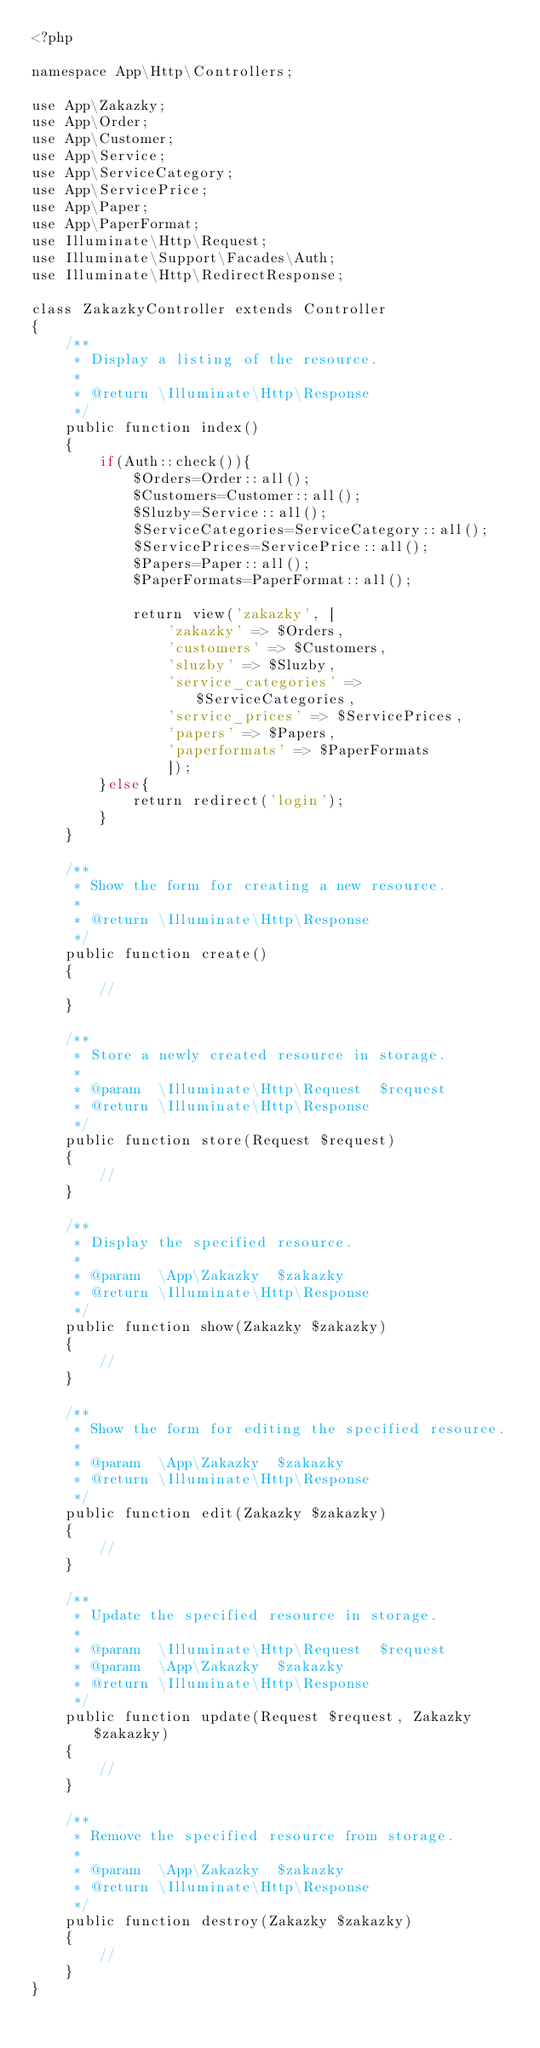<code> <loc_0><loc_0><loc_500><loc_500><_PHP_><?php

namespace App\Http\Controllers;

use App\Zakazky;
use App\Order;
use App\Customer;
use App\Service;
use App\ServiceCategory;
use App\ServicePrice;
use App\Paper;
use App\PaperFormat;
use Illuminate\Http\Request;
use Illuminate\Support\Facades\Auth;
use Illuminate\Http\RedirectResponse;

class ZakazkyController extends Controller
{
    /**
     * Display a listing of the resource.
     *
     * @return \Illuminate\Http\Response
     */
    public function index()
    {
        if(Auth::check()){
            $Orders=Order::all();
            $Customers=Customer::all();
            $Sluzby=Service::all();
            $ServiceCategories=ServiceCategory::all();
            $ServicePrices=ServicePrice::all();
            $Papers=Paper::all();
            $PaperFormats=PaperFormat::all();

            return view('zakazky', [
                'zakazky' => $Orders, 
                'customers' => $Customers, 
                'sluzby' => $Sluzby, 
                'service_categories' => $ServiceCategories, 
                'service_prices' => $ServicePrices,
                'papers' => $Papers, 
                'paperformats' => $PaperFormats 
                ]);
        }else{
            return redirect('login');
        }
    }

    /**
     * Show the form for creating a new resource.
     *
     * @return \Illuminate\Http\Response
     */
    public function create()
    {
        //
    }

    /**
     * Store a newly created resource in storage.
     *
     * @param  \Illuminate\Http\Request  $request
     * @return \Illuminate\Http\Response
     */
    public function store(Request $request)
    {
        //
    }

    /**
     * Display the specified resource.
     *
     * @param  \App\Zakazky  $zakazky
     * @return \Illuminate\Http\Response
     */
    public function show(Zakazky $zakazky)
    {
        //
    }

    /**
     * Show the form for editing the specified resource.
     *
     * @param  \App\Zakazky  $zakazky
     * @return \Illuminate\Http\Response
     */
    public function edit(Zakazky $zakazky)
    {
        //
    }

    /**
     * Update the specified resource in storage.
     *
     * @param  \Illuminate\Http\Request  $request
     * @param  \App\Zakazky  $zakazky
     * @return \Illuminate\Http\Response
     */
    public function update(Request $request, Zakazky $zakazky)
    {
        //
    }

    /**
     * Remove the specified resource from storage.
     *
     * @param  \App\Zakazky  $zakazky
     * @return \Illuminate\Http\Response
     */
    public function destroy(Zakazky $zakazky)
    {
        //
    }
}
</code> 